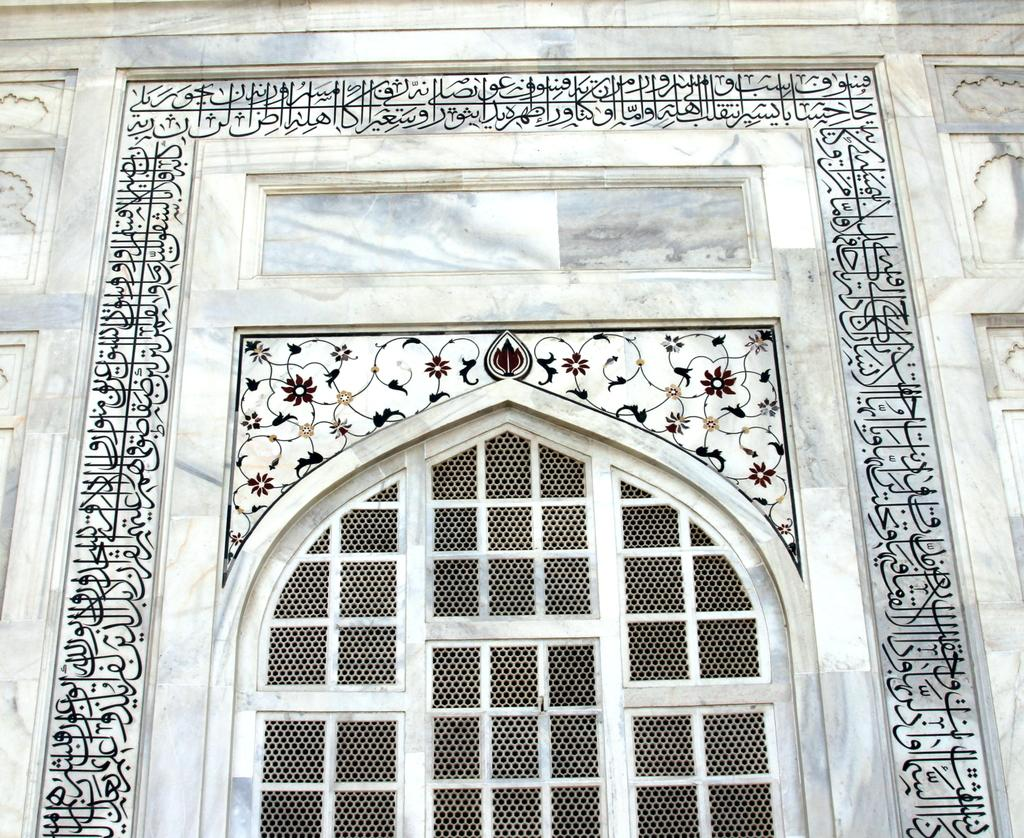What type of structure can be seen in the image? There is a building in the image, but it appears to be partially visible. What architectural features are visible in the image? There are walls visible in the image. Is there any entrance visible in the image? Yes, there is a door in the image. What type of grain is being harvested in the image? There is no grain or harvesting activity present in the image; it features a building with walls and a door. 